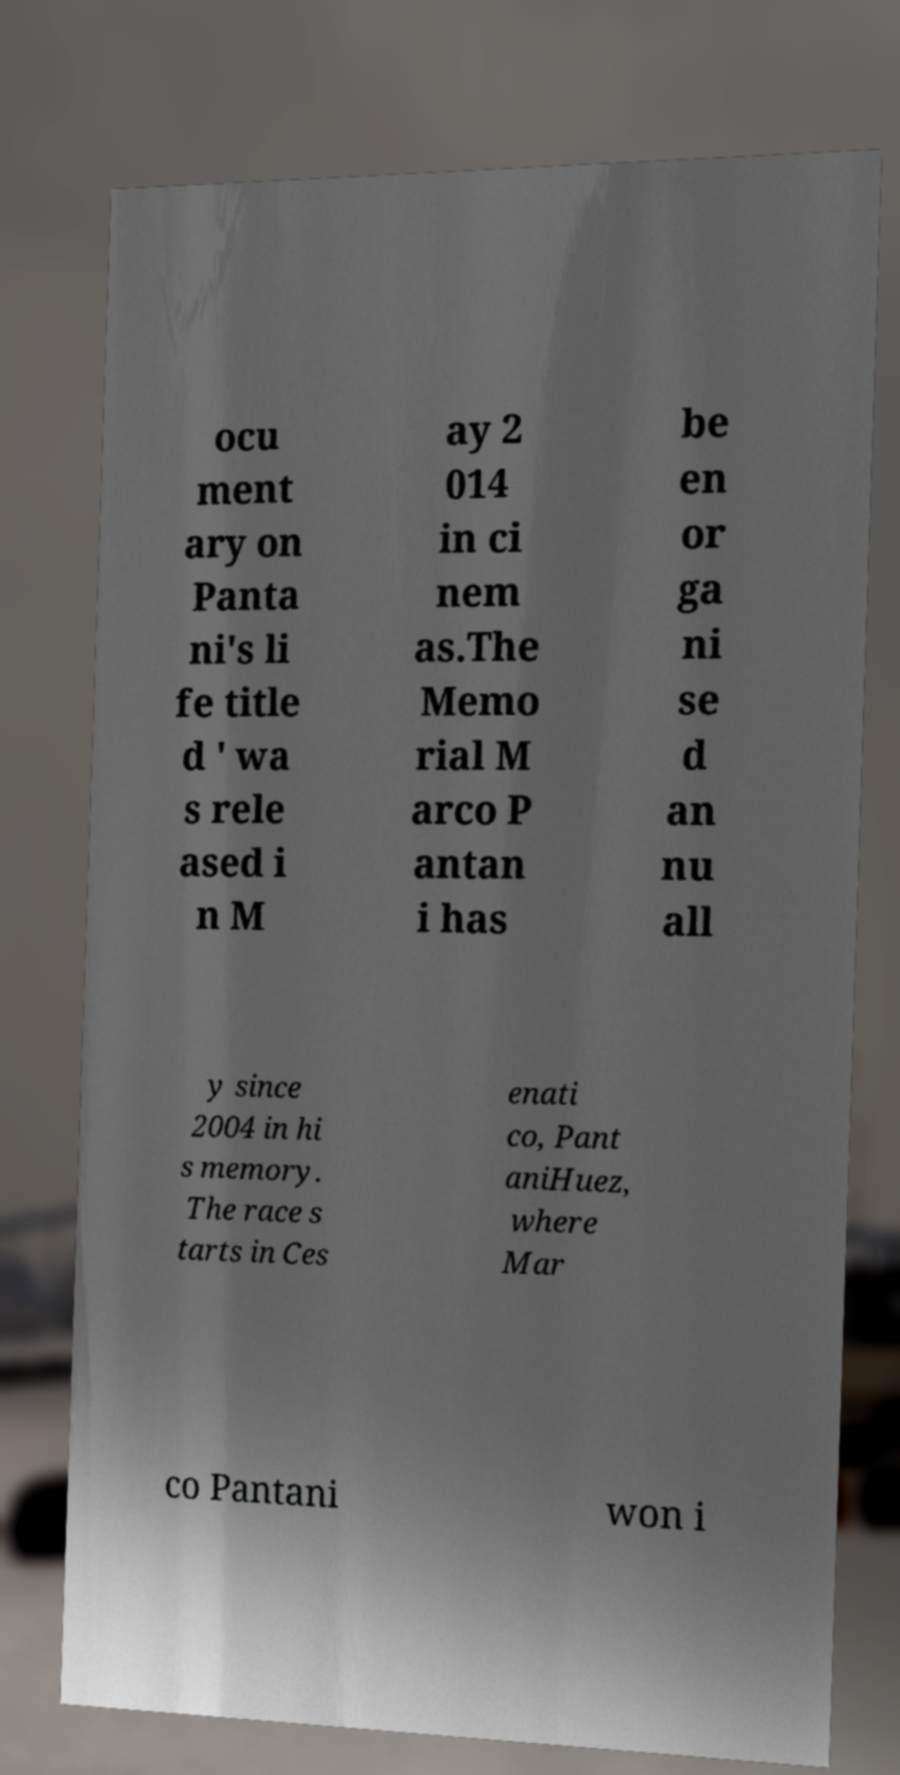Please read and relay the text visible in this image. What does it say? ocu ment ary on Panta ni's li fe title d ' wa s rele ased i n M ay 2 014 in ci nem as.The Memo rial M arco P antan i has be en or ga ni se d an nu all y since 2004 in hi s memory. The race s tarts in Ces enati co, Pant aniHuez, where Mar co Pantani won i 